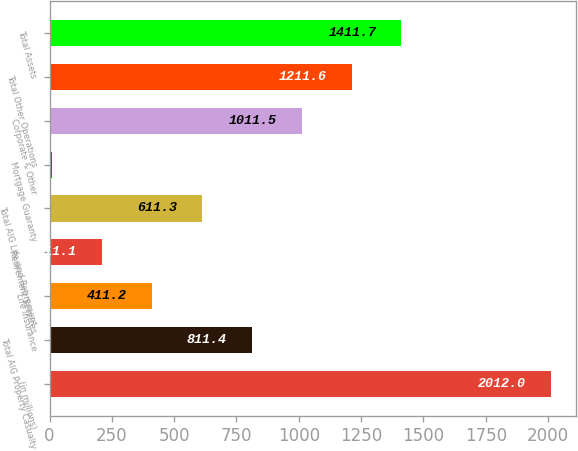Convert chart to OTSL. <chart><loc_0><loc_0><loc_500><loc_500><bar_chart><fcel>(in millions)<fcel>Total AIG Property Casualty<fcel>Life Insurance<fcel>Retirement Services<fcel>Total AIG Life and Retirement<fcel>Mortgage Guaranty<fcel>Corporate & Other<fcel>Total Other Operations<fcel>Total Assets<nl><fcel>2012<fcel>811.4<fcel>411.2<fcel>211.1<fcel>611.3<fcel>11<fcel>1011.5<fcel>1211.6<fcel>1411.7<nl></chart> 